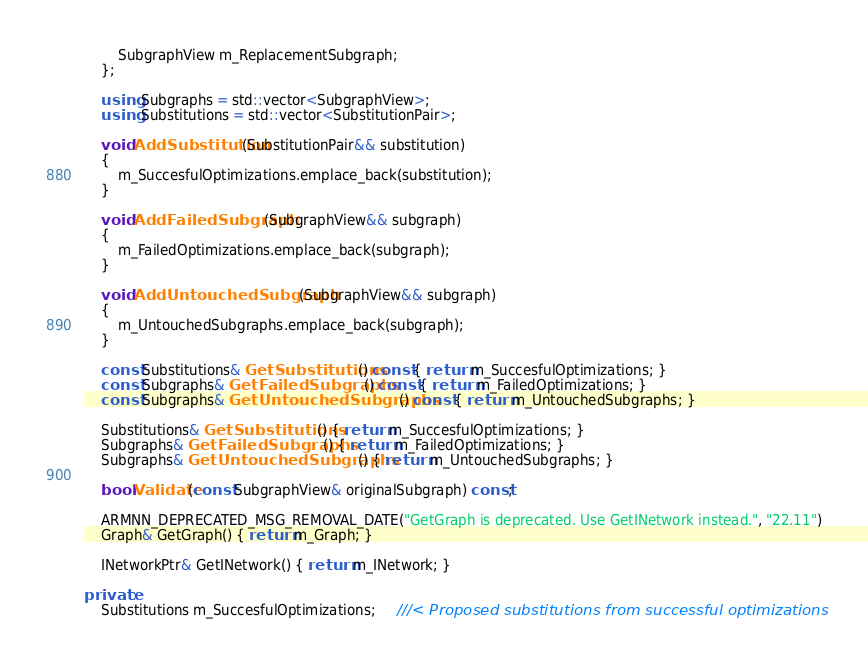<code> <loc_0><loc_0><loc_500><loc_500><_C++_>        SubgraphView m_ReplacementSubgraph;
    };

    using Subgraphs = std::vector<SubgraphView>;
    using Substitutions = std::vector<SubstitutionPair>;

    void AddSubstitution(SubstitutionPair&& substitution)
    {
        m_SuccesfulOptimizations.emplace_back(substitution);
    }

    void AddFailedSubgraph(SubgraphView&& subgraph)
    {
        m_FailedOptimizations.emplace_back(subgraph);
    }

    void AddUntouchedSubgraph(SubgraphView&& subgraph)
    {
        m_UntouchedSubgraphs.emplace_back(subgraph);
    }

    const Substitutions& GetSubstitutions() const { return m_SuccesfulOptimizations; }
    const Subgraphs& GetFailedSubgraphs() const { return m_FailedOptimizations; }
    const Subgraphs& GetUntouchedSubgraphs() const { return m_UntouchedSubgraphs; }

    Substitutions& GetSubstitutions() { return m_SuccesfulOptimizations; }
    Subgraphs& GetFailedSubgraphs() { return m_FailedOptimizations; }
    Subgraphs& GetUntouchedSubgraphs() { return m_UntouchedSubgraphs; }

    bool Validate(const SubgraphView& originalSubgraph) const;

    ARMNN_DEPRECATED_MSG_REMOVAL_DATE("GetGraph is deprecated. Use GetINetwork instead.", "22.11")
    Graph& GetGraph() { return m_Graph; }

    INetworkPtr& GetINetwork() { return m_INetwork; }

private:
    Substitutions m_SuccesfulOptimizations;     ///< Proposed substitutions from successful optimizations</code> 